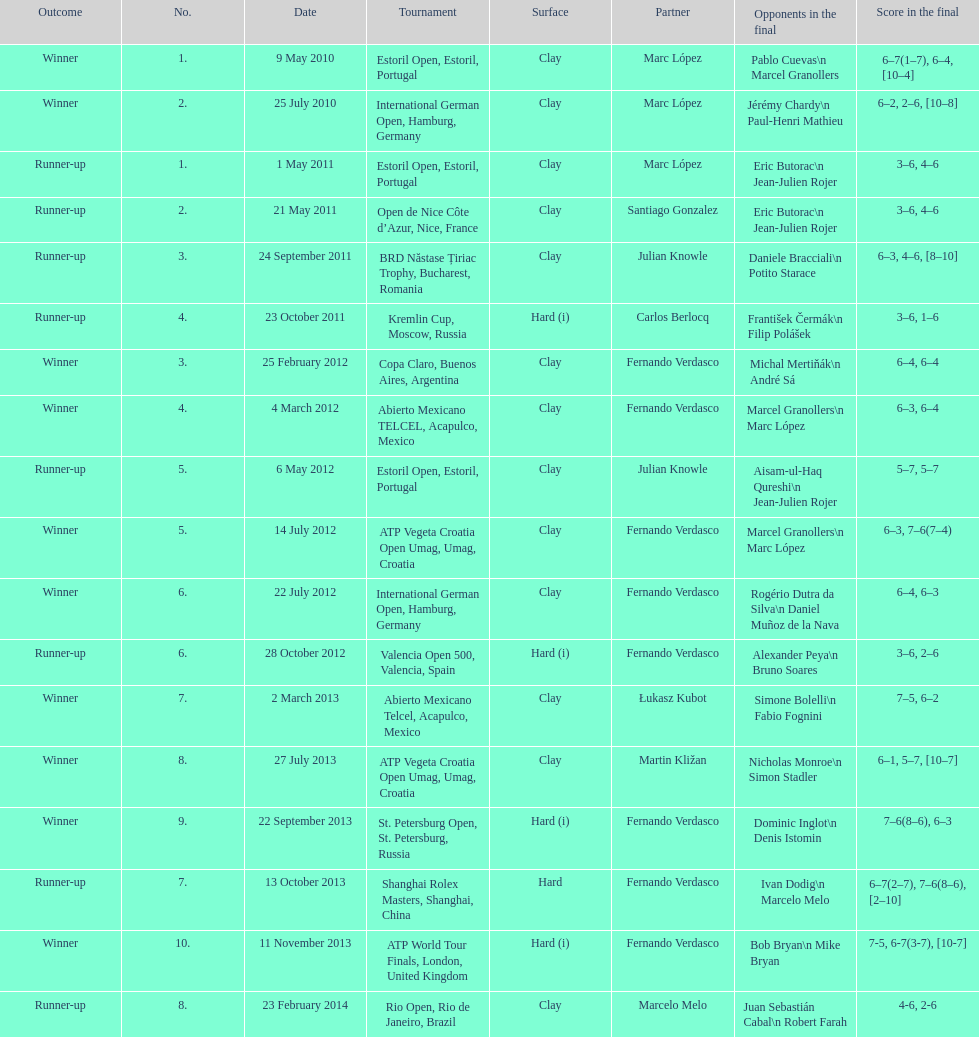How many contests has this player triumphed in during his professional journey thus far? 10. 